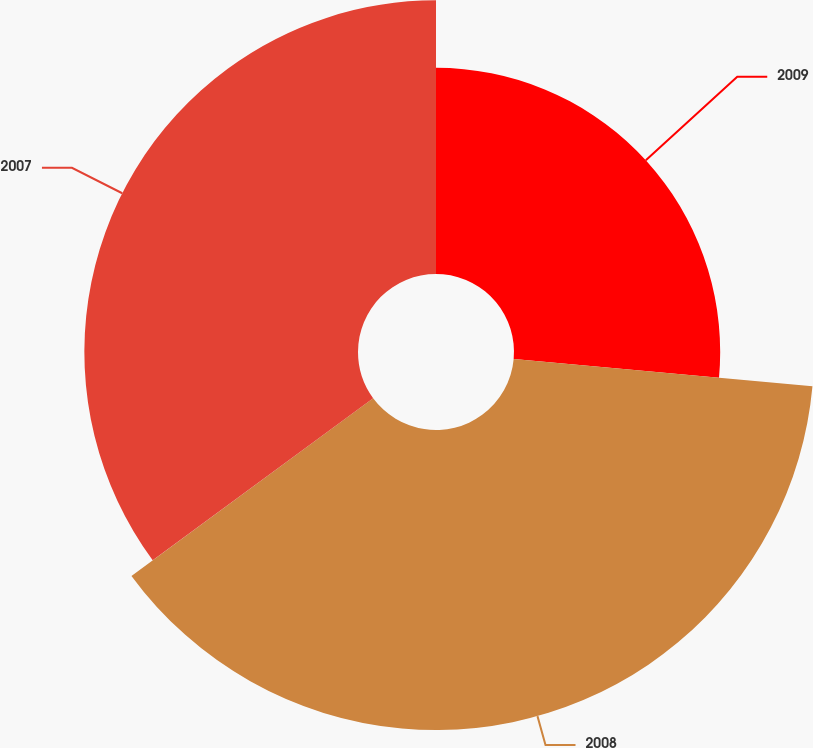Convert chart to OTSL. <chart><loc_0><loc_0><loc_500><loc_500><pie_chart><fcel>2009<fcel>2008<fcel>2007<nl><fcel>26.44%<fcel>38.47%<fcel>35.09%<nl></chart> 